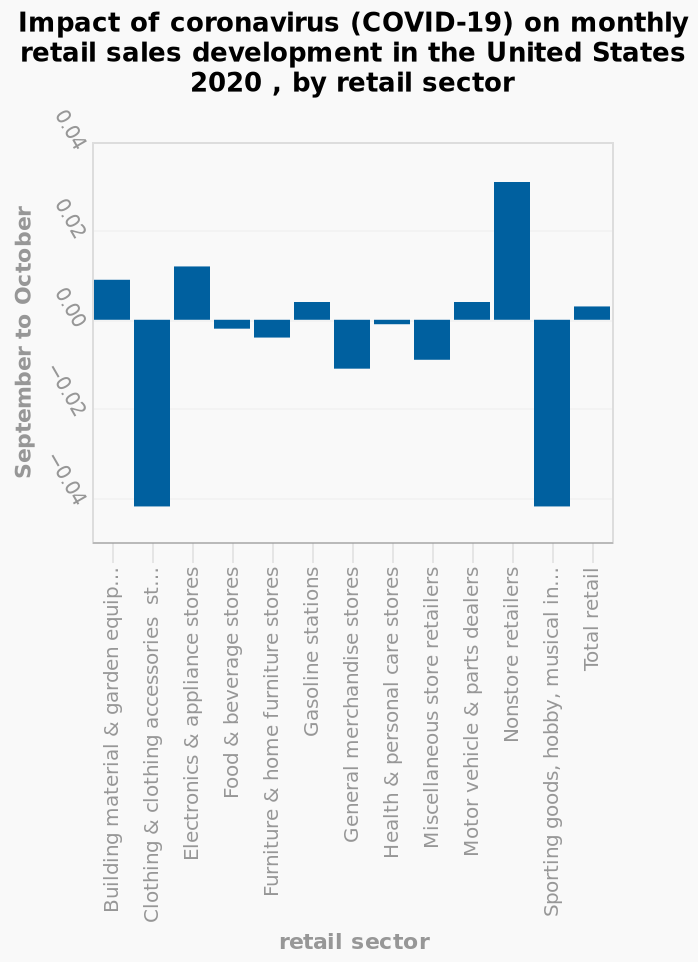<image>
please summary the statistics and relations of the chart The non-store retail sector saw the biggest improvement, whereas clothing and sporting goods sectors experienced the biggest loss. What is the title of the bar chart? The title of the bar chart is "Impact of coronavirus (COVID-19) on monthly retail sales development in the United States 2020, by retail sector." What is the range of values on the y-axis?  The range of values on the y-axis is from -0.04 to 0.04. Describe the following image in detail This bar chart is called Impact of coronavirus (COVID-19) on monthly retail sales development in the United States 2020 , by retail sector. The y-axis plots September to October along a categorical scale with −0.04 on one end and 0.04 at the other. On the x-axis, retail sector is plotted on a categorical scale from Building material & garden equipment & supplies dealers to Total retail. What effect has Covid had on health stores?  Covid has had little effect on health stores. 